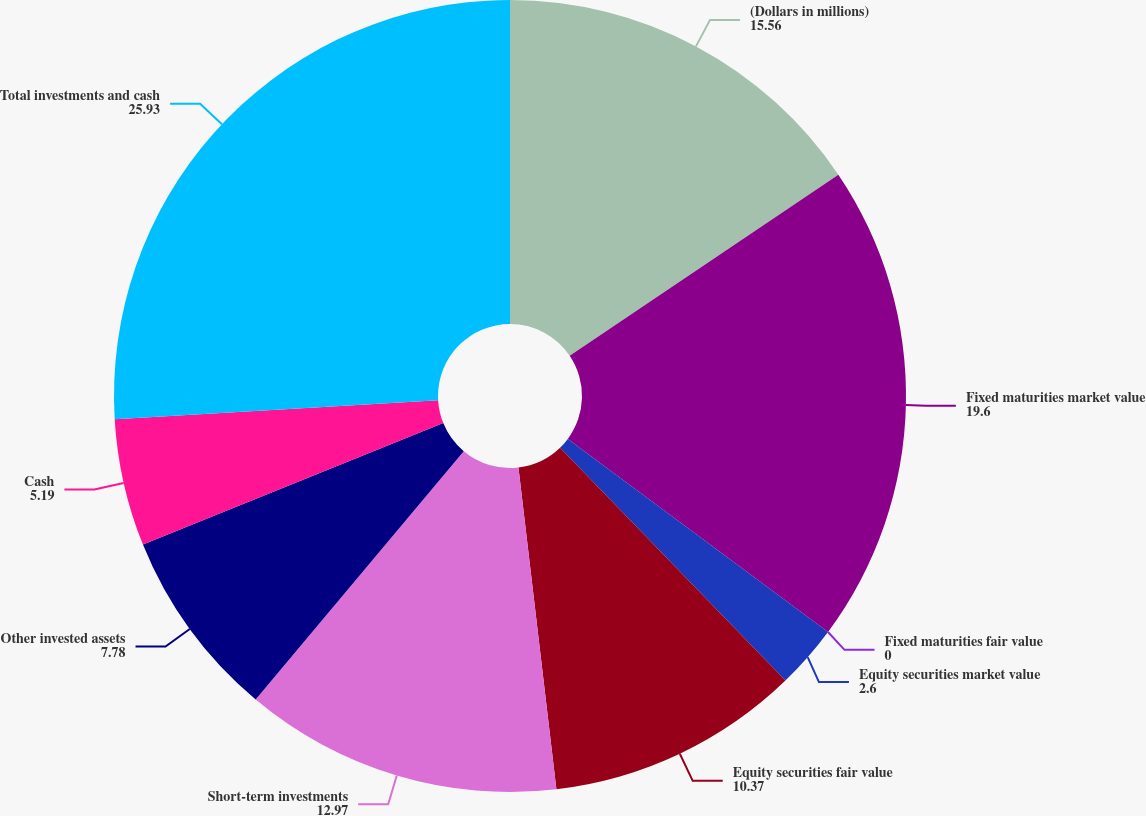Convert chart to OTSL. <chart><loc_0><loc_0><loc_500><loc_500><pie_chart><fcel>(Dollars in millions)<fcel>Fixed maturities market value<fcel>Fixed maturities fair value<fcel>Equity securities market value<fcel>Equity securities fair value<fcel>Short-term investments<fcel>Other invested assets<fcel>Cash<fcel>Total investments and cash<nl><fcel>15.56%<fcel>19.6%<fcel>0.0%<fcel>2.6%<fcel>10.37%<fcel>12.97%<fcel>7.78%<fcel>5.19%<fcel>25.93%<nl></chart> 